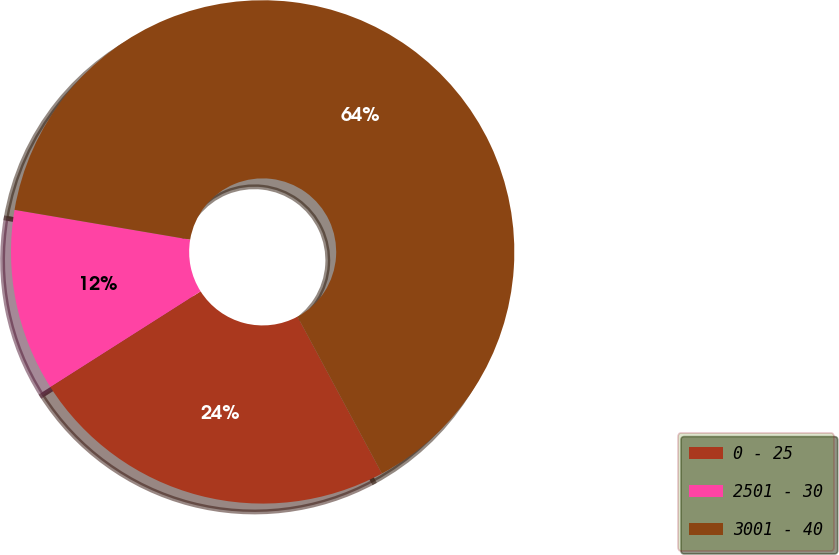Convert chart. <chart><loc_0><loc_0><loc_500><loc_500><pie_chart><fcel>0 - 25<fcel>2501 - 30<fcel>3001 - 40<nl><fcel>23.84%<fcel>11.69%<fcel>64.47%<nl></chart> 